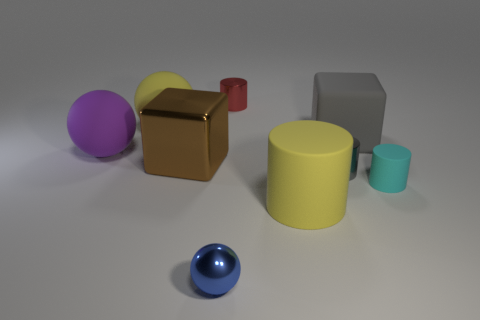Is there any other thing that is the same shape as the big purple rubber object?
Keep it short and to the point. Yes. What number of things are large gray rubber things or cyan rubber cylinders?
Keep it short and to the point. 2. There is a red metallic object; is its shape the same as the large yellow thing that is on the right side of the small sphere?
Keep it short and to the point. Yes. There is a rubber thing to the left of the big yellow matte sphere; what shape is it?
Your answer should be very brief. Sphere. Do the gray rubber thing and the purple object have the same shape?
Ensure brevity in your answer.  No. What size is the yellow matte object that is the same shape as the purple matte thing?
Offer a very short reply. Large. Is the size of the rubber object that is behind the matte block the same as the tiny blue metal thing?
Your answer should be very brief. No. There is a rubber object that is on the right side of the blue metallic thing and to the left of the gray rubber thing; what is its size?
Your response must be concise. Large. There is a thing that is the same color as the big matte block; what is its material?
Provide a short and direct response. Metal. How many other matte balls have the same color as the small sphere?
Provide a short and direct response. 0. 